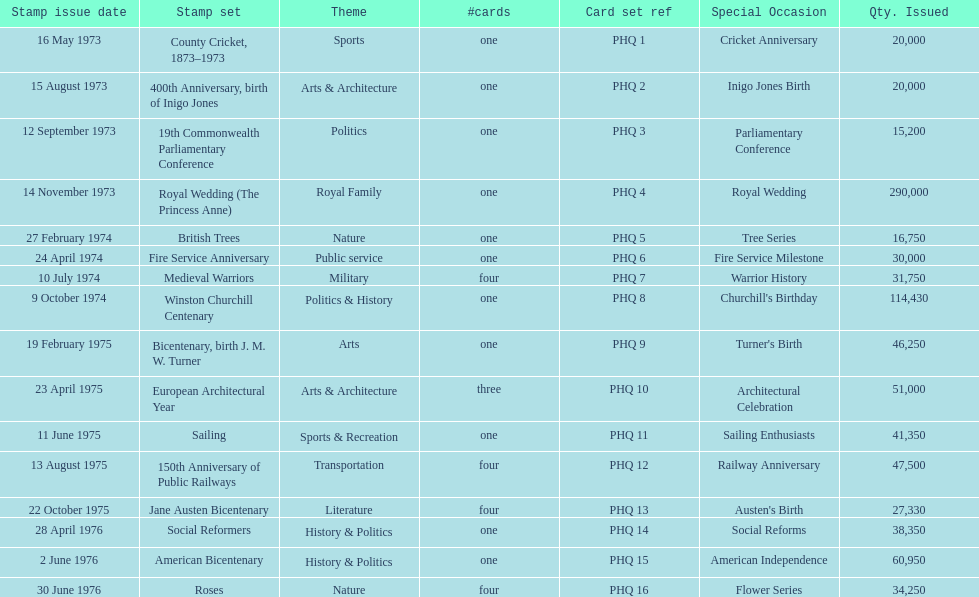How many stamp sets were released in the year 1975? 5. 